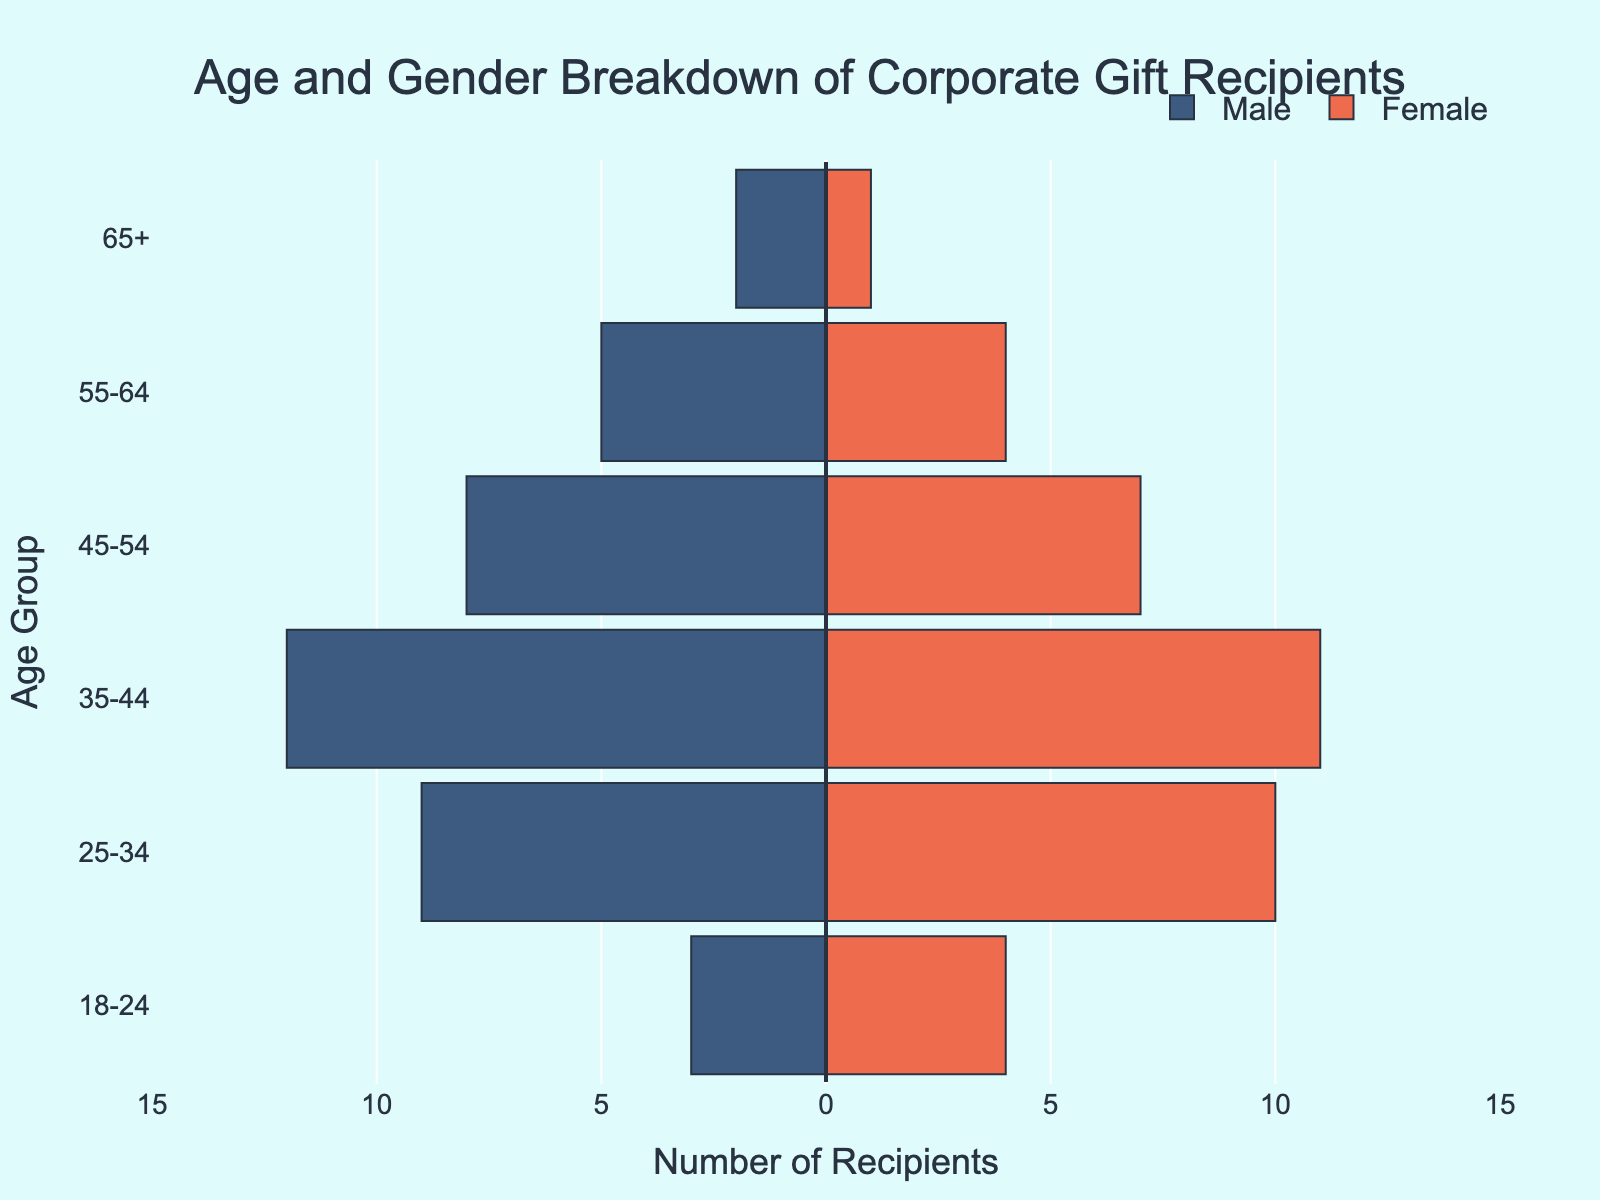What is the title of the figure? The title is typically positioned at the top of the plot. By reading it, we can identify the main topic or the focus of the visual data presented.
Answer: Age and Gender Breakdown of Corporate Gift Recipients How are the age groups ordered in the plot? Observe the arrangement of the age groups on the y-axis. They are listed from the oldest at the top to the youngest at the bottom.
Answer: From oldest (65+) to youngest (18-24) Which gender has the highest number of recipients in the 35-44 age group? By comparing the bar lengths for both genders in the 35-44 category, we can determine which one is longer.
Answer: Male What is the total number of female recipients in the 18-24 and 25-34 age groups? Find the bar lengths for both categories for females and sum them up: 4 (18-24) + 10 (25-34).
Answer: 14 Which age group has the smallest difference in the number of male and female recipients? Compare the bar lengths for each age group across genders and calculate the differences. The group with the smallest difference is the answer.
Answer: 25-34 How does the number of male recipients in the 45-54 age group compare to the number of female recipients in the 55-64 age group? Look at the bar lengths for males in 45-54 and females in 55-64. Compare these two values directly.
Answer: More males in 45-54 What is the total number of recipients in the 65+ age group? Sum the number of male and female recipients in the 65+ age group: 2 (Male) + 1 (Female).
Answer: 3 Which gender has fewer recipients overall across all age groups? Add the number of recipients for each gender across all age groups and compare the totals.
Answer: Female What is the difference in the number of male and female recipients in the 45-54 age group? Determine the number of male and female recipients in 45-54, then calculate the difference: 8 (Male) - 7 (Female).
Answer: 1 In which age group do females have the highest number of recipients? Find the age group where the female bar is the longest.
Answer: 25-34 